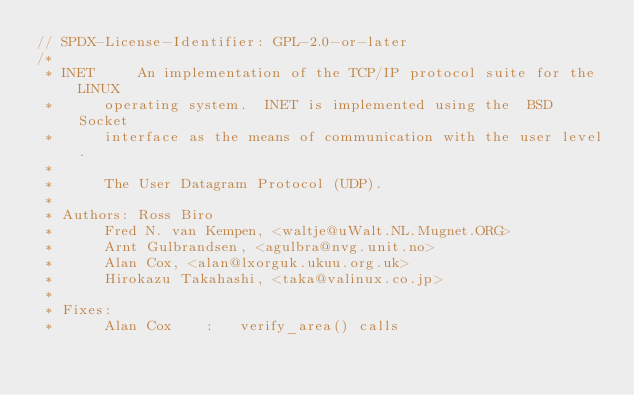<code> <loc_0><loc_0><loc_500><loc_500><_C_>// SPDX-License-Identifier: GPL-2.0-or-later
/*
 * INET		An implementation of the TCP/IP protocol suite for the LINUX
 *		operating system.  INET is implemented using the  BSD Socket
 *		interface as the means of communication with the user level.
 *
 *		The User Datagram Protocol (UDP).
 *
 * Authors:	Ross Biro
 *		Fred N. van Kempen, <waltje@uWalt.NL.Mugnet.ORG>
 *		Arnt Gulbrandsen, <agulbra@nvg.unit.no>
 *		Alan Cox, <alan@lxorguk.ukuu.org.uk>
 *		Hirokazu Takahashi, <taka@valinux.co.jp>
 *
 * Fixes:
 *		Alan Cox	:	verify_area() calls</code> 